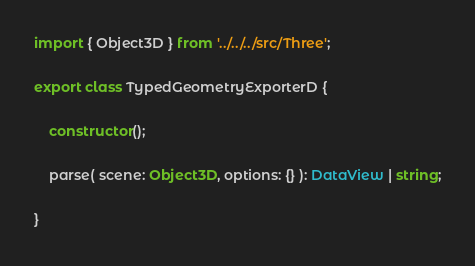<code> <loc_0><loc_0><loc_500><loc_500><_TypeScript_>import { Object3D } from '../../../src/Three';

export class TypedGeometryExporterD {

	constructor();

	parse( scene: Object3D, options: {} ): DataView | string;

}
</code> 